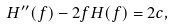<formula> <loc_0><loc_0><loc_500><loc_500>H ^ { \prime \prime } ( f ) - 2 f H ( f ) = 2 c ,</formula> 